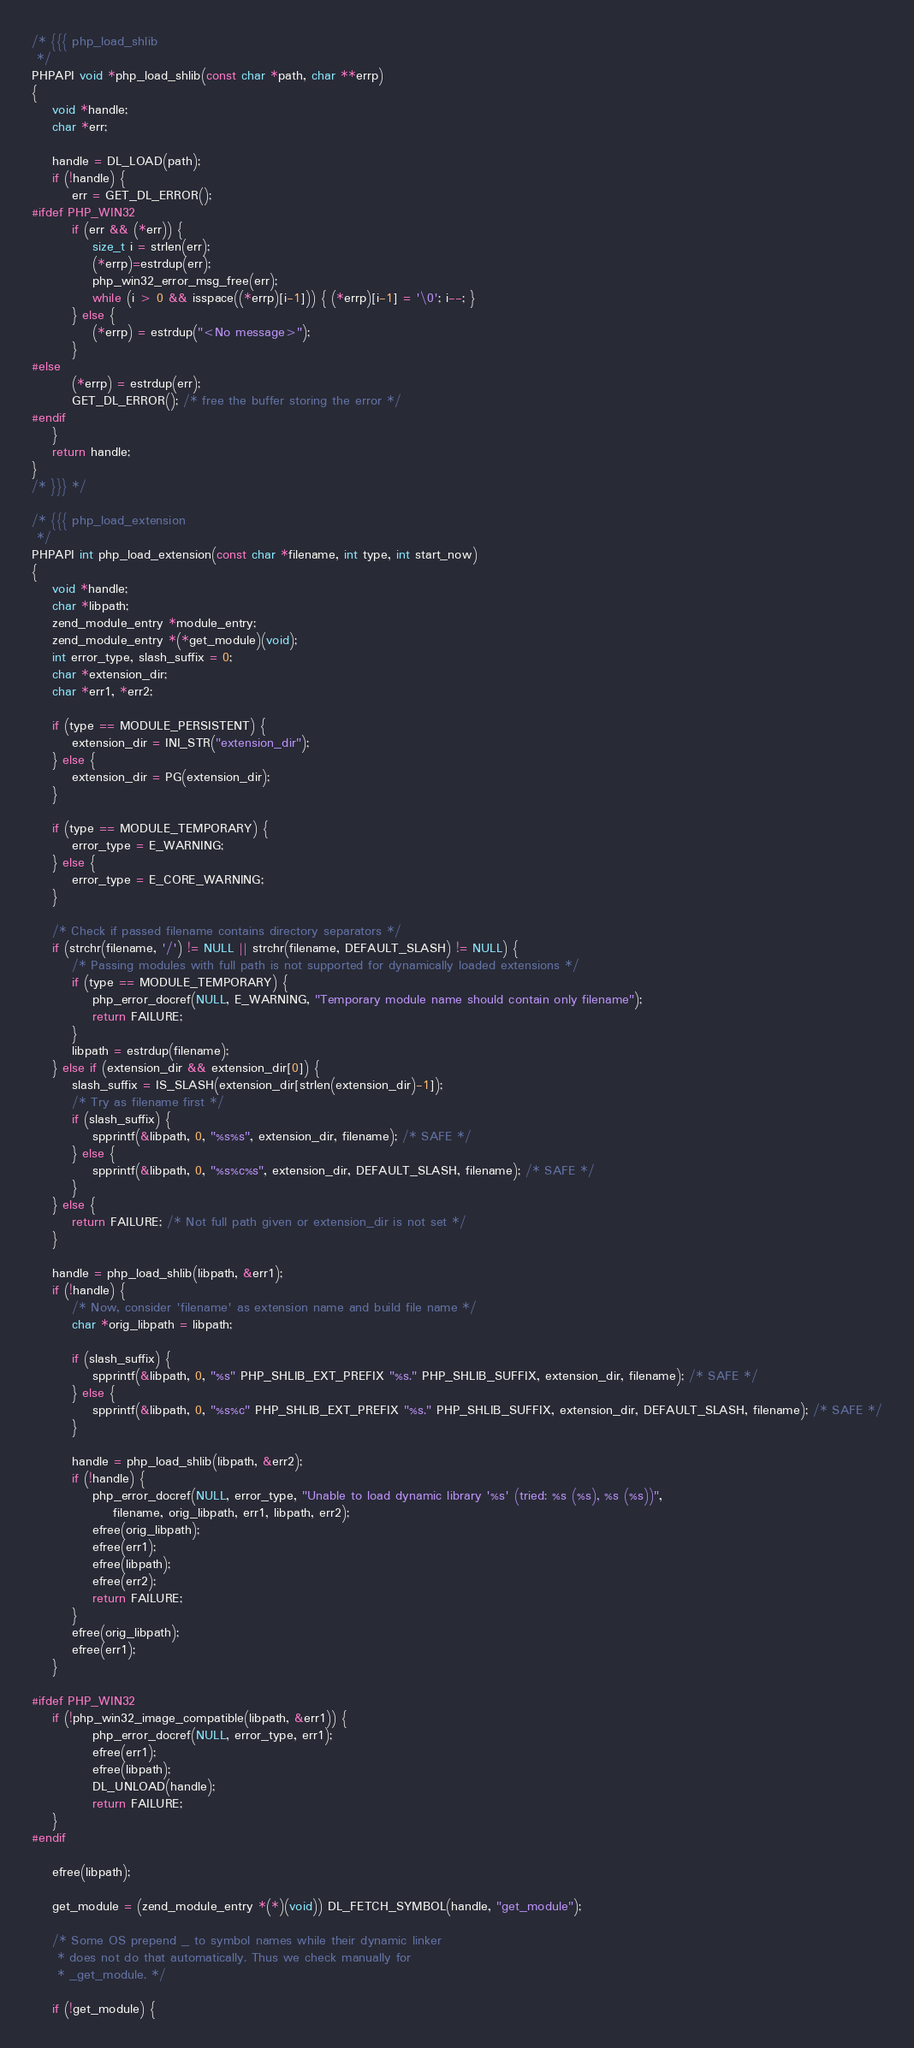Convert code to text. <code><loc_0><loc_0><loc_500><loc_500><_C_>
/* {{{ php_load_shlib
 */
PHPAPI void *php_load_shlib(const char *path, char **errp)
{
	void *handle;
	char *err;

	handle = DL_LOAD(path);
	if (!handle) {
		err = GET_DL_ERROR();
#ifdef PHP_WIN32
		if (err && (*err)) {
			size_t i = strlen(err);
			(*errp)=estrdup(err);
			php_win32_error_msg_free(err);
			while (i > 0 && isspace((*errp)[i-1])) { (*errp)[i-1] = '\0'; i--; }
		} else {
			(*errp) = estrdup("<No message>");
		}
#else
		(*errp) = estrdup(err);
		GET_DL_ERROR(); /* free the buffer storing the error */
#endif
	}
	return handle;
}
/* }}} */

/* {{{ php_load_extension
 */
PHPAPI int php_load_extension(const char *filename, int type, int start_now)
{
	void *handle;
	char *libpath;
	zend_module_entry *module_entry;
	zend_module_entry *(*get_module)(void);
	int error_type, slash_suffix = 0;
	char *extension_dir;
	char *err1, *err2;

	if (type == MODULE_PERSISTENT) {
		extension_dir = INI_STR("extension_dir");
	} else {
		extension_dir = PG(extension_dir);
	}

	if (type == MODULE_TEMPORARY) {
		error_type = E_WARNING;
	} else {
		error_type = E_CORE_WARNING;
	}

	/* Check if passed filename contains directory separators */
	if (strchr(filename, '/') != NULL || strchr(filename, DEFAULT_SLASH) != NULL) {
		/* Passing modules with full path is not supported for dynamically loaded extensions */
		if (type == MODULE_TEMPORARY) {
			php_error_docref(NULL, E_WARNING, "Temporary module name should contain only filename");
			return FAILURE;
		}
		libpath = estrdup(filename);
	} else if (extension_dir && extension_dir[0]) {
		slash_suffix = IS_SLASH(extension_dir[strlen(extension_dir)-1]);
		/* Try as filename first */
		if (slash_suffix) {
			spprintf(&libpath, 0, "%s%s", extension_dir, filename); /* SAFE */
		} else {
			spprintf(&libpath, 0, "%s%c%s", extension_dir, DEFAULT_SLASH, filename); /* SAFE */
		}
	} else {
		return FAILURE; /* Not full path given or extension_dir is not set */
	}

	handle = php_load_shlib(libpath, &err1);
	if (!handle) {
		/* Now, consider 'filename' as extension name and build file name */
		char *orig_libpath = libpath;

		if (slash_suffix) {
			spprintf(&libpath, 0, "%s" PHP_SHLIB_EXT_PREFIX "%s." PHP_SHLIB_SUFFIX, extension_dir, filename); /* SAFE */
		} else {
			spprintf(&libpath, 0, "%s%c" PHP_SHLIB_EXT_PREFIX "%s." PHP_SHLIB_SUFFIX, extension_dir, DEFAULT_SLASH, filename); /* SAFE */
		}

		handle = php_load_shlib(libpath, &err2);
		if (!handle) {
			php_error_docref(NULL, error_type, "Unable to load dynamic library '%s' (tried: %s (%s), %s (%s))",
				filename, orig_libpath, err1, libpath, err2);
			efree(orig_libpath);
			efree(err1);
			efree(libpath);
			efree(err2);
			return FAILURE;
		}
		efree(orig_libpath);
		efree(err1);
	}

#ifdef PHP_WIN32
	if (!php_win32_image_compatible(libpath, &err1)) {
			php_error_docref(NULL, error_type, err1);
			efree(err1);
			efree(libpath);
			DL_UNLOAD(handle);
			return FAILURE;
	}
#endif

	efree(libpath);

	get_module = (zend_module_entry *(*)(void)) DL_FETCH_SYMBOL(handle, "get_module");

	/* Some OS prepend _ to symbol names while their dynamic linker
	 * does not do that automatically. Thus we check manually for
	 * _get_module. */

	if (!get_module) {</code> 